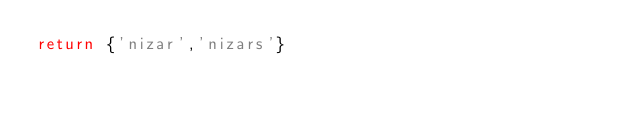Convert code to text. <code><loc_0><loc_0><loc_500><loc_500><_Lua_>return {'nizar','nizars'}</code> 